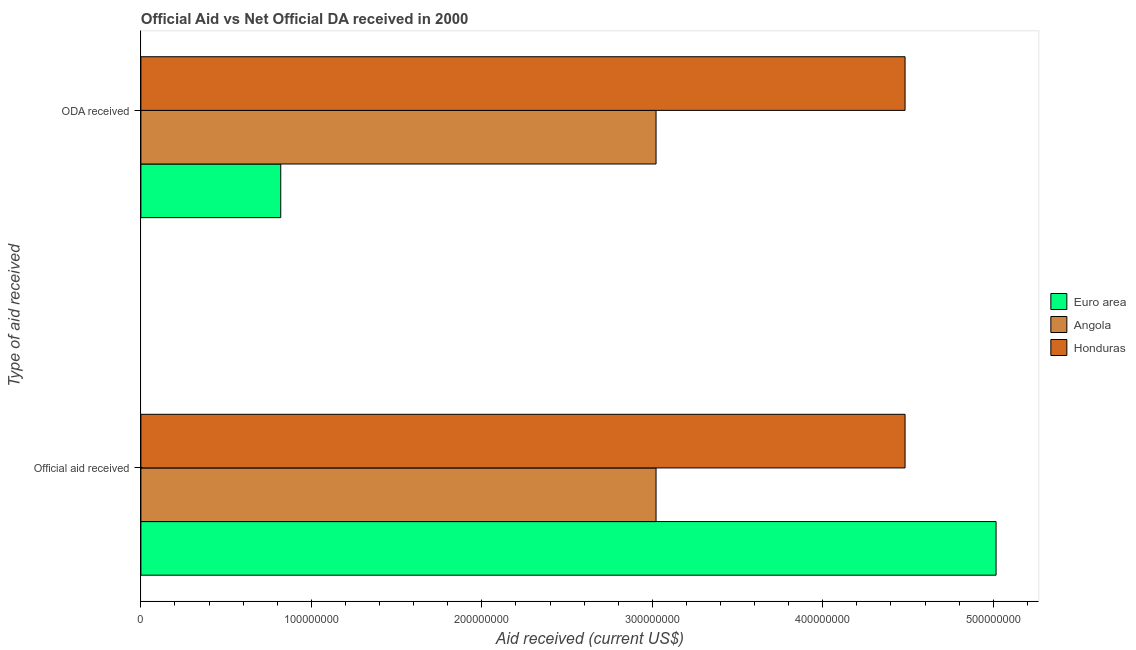How many different coloured bars are there?
Provide a short and direct response. 3. Are the number of bars per tick equal to the number of legend labels?
Your response must be concise. Yes. How many bars are there on the 2nd tick from the bottom?
Provide a succinct answer. 3. What is the label of the 1st group of bars from the top?
Provide a succinct answer. ODA received. What is the oda received in Honduras?
Your response must be concise. 4.48e+08. Across all countries, what is the maximum official aid received?
Your response must be concise. 5.02e+08. Across all countries, what is the minimum official aid received?
Make the answer very short. 3.02e+08. In which country was the oda received maximum?
Your response must be concise. Honduras. In which country was the official aid received minimum?
Give a very brief answer. Angola. What is the total oda received in the graph?
Offer a terse response. 8.33e+08. What is the difference between the official aid received in Honduras and that in Euro area?
Keep it short and to the point. -5.34e+07. What is the difference between the oda received in Euro area and the official aid received in Angola?
Your answer should be compact. -2.20e+08. What is the average oda received per country?
Your answer should be very brief. 2.78e+08. What is the difference between the official aid received and oda received in Euro area?
Keep it short and to the point. 4.20e+08. In how many countries, is the oda received greater than 260000000 US$?
Offer a terse response. 2. What is the ratio of the oda received in Euro area to that in Honduras?
Your answer should be compact. 0.18. Is the official aid received in Angola less than that in Euro area?
Your answer should be compact. Yes. What does the 1st bar from the top in Official aid received represents?
Your answer should be compact. Honduras. What does the 1st bar from the bottom in Official aid received represents?
Keep it short and to the point. Euro area. What is the difference between two consecutive major ticks on the X-axis?
Your response must be concise. 1.00e+08. Where does the legend appear in the graph?
Offer a terse response. Center right. How many legend labels are there?
Provide a succinct answer. 3. How are the legend labels stacked?
Offer a very short reply. Vertical. What is the title of the graph?
Ensure brevity in your answer.  Official Aid vs Net Official DA received in 2000 . Does "Bahamas" appear as one of the legend labels in the graph?
Offer a very short reply. No. What is the label or title of the X-axis?
Keep it short and to the point. Aid received (current US$). What is the label or title of the Y-axis?
Give a very brief answer. Type of aid received. What is the Aid received (current US$) of Euro area in Official aid received?
Keep it short and to the point. 5.02e+08. What is the Aid received (current US$) in Angola in Official aid received?
Provide a short and direct response. 3.02e+08. What is the Aid received (current US$) of Honduras in Official aid received?
Your response must be concise. 4.48e+08. What is the Aid received (current US$) of Euro area in ODA received?
Keep it short and to the point. 8.20e+07. What is the Aid received (current US$) of Angola in ODA received?
Keep it short and to the point. 3.02e+08. What is the Aid received (current US$) of Honduras in ODA received?
Your answer should be compact. 4.48e+08. Across all Type of aid received, what is the maximum Aid received (current US$) in Euro area?
Your answer should be compact. 5.02e+08. Across all Type of aid received, what is the maximum Aid received (current US$) of Angola?
Make the answer very short. 3.02e+08. Across all Type of aid received, what is the maximum Aid received (current US$) in Honduras?
Your answer should be compact. 4.48e+08. Across all Type of aid received, what is the minimum Aid received (current US$) in Euro area?
Your answer should be very brief. 8.20e+07. Across all Type of aid received, what is the minimum Aid received (current US$) of Angola?
Your answer should be very brief. 3.02e+08. Across all Type of aid received, what is the minimum Aid received (current US$) in Honduras?
Ensure brevity in your answer.  4.48e+08. What is the total Aid received (current US$) in Euro area in the graph?
Ensure brevity in your answer.  5.84e+08. What is the total Aid received (current US$) in Angola in the graph?
Provide a succinct answer. 6.04e+08. What is the total Aid received (current US$) of Honduras in the graph?
Offer a terse response. 8.97e+08. What is the difference between the Aid received (current US$) of Euro area in Official aid received and that in ODA received?
Provide a short and direct response. 4.20e+08. What is the difference between the Aid received (current US$) in Honduras in Official aid received and that in ODA received?
Your answer should be compact. 0. What is the difference between the Aid received (current US$) in Euro area in Official aid received and the Aid received (current US$) in Angola in ODA received?
Your answer should be very brief. 1.99e+08. What is the difference between the Aid received (current US$) in Euro area in Official aid received and the Aid received (current US$) in Honduras in ODA received?
Provide a succinct answer. 5.34e+07. What is the difference between the Aid received (current US$) of Angola in Official aid received and the Aid received (current US$) of Honduras in ODA received?
Ensure brevity in your answer.  -1.46e+08. What is the average Aid received (current US$) of Euro area per Type of aid received?
Offer a very short reply. 2.92e+08. What is the average Aid received (current US$) in Angola per Type of aid received?
Your response must be concise. 3.02e+08. What is the average Aid received (current US$) of Honduras per Type of aid received?
Your answer should be very brief. 4.48e+08. What is the difference between the Aid received (current US$) in Euro area and Aid received (current US$) in Angola in Official aid received?
Offer a terse response. 1.99e+08. What is the difference between the Aid received (current US$) in Euro area and Aid received (current US$) in Honduras in Official aid received?
Keep it short and to the point. 5.34e+07. What is the difference between the Aid received (current US$) in Angola and Aid received (current US$) in Honduras in Official aid received?
Ensure brevity in your answer.  -1.46e+08. What is the difference between the Aid received (current US$) of Euro area and Aid received (current US$) of Angola in ODA received?
Your answer should be very brief. -2.20e+08. What is the difference between the Aid received (current US$) of Euro area and Aid received (current US$) of Honduras in ODA received?
Provide a short and direct response. -3.66e+08. What is the difference between the Aid received (current US$) in Angola and Aid received (current US$) in Honduras in ODA received?
Provide a succinct answer. -1.46e+08. What is the ratio of the Aid received (current US$) in Euro area in Official aid received to that in ODA received?
Make the answer very short. 6.11. What is the ratio of the Aid received (current US$) of Angola in Official aid received to that in ODA received?
Give a very brief answer. 1. What is the ratio of the Aid received (current US$) of Honduras in Official aid received to that in ODA received?
Offer a very short reply. 1. What is the difference between the highest and the second highest Aid received (current US$) in Euro area?
Ensure brevity in your answer.  4.20e+08. What is the difference between the highest and the lowest Aid received (current US$) of Euro area?
Ensure brevity in your answer.  4.20e+08. What is the difference between the highest and the lowest Aid received (current US$) of Angola?
Provide a short and direct response. 0. 